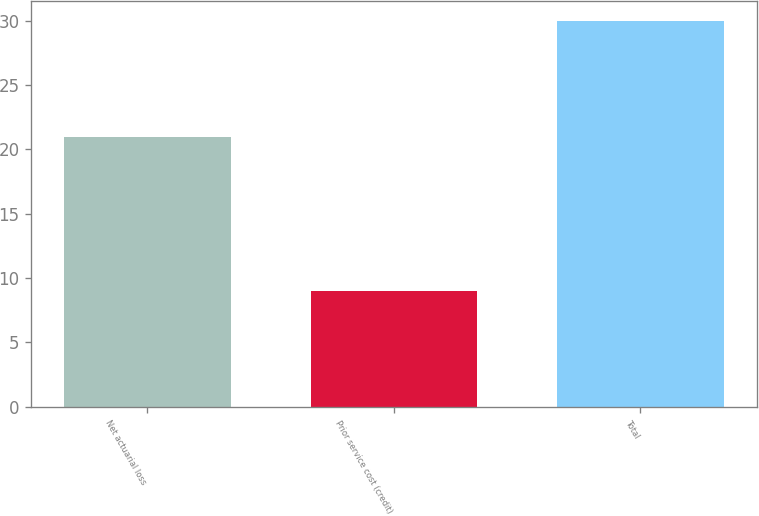<chart> <loc_0><loc_0><loc_500><loc_500><bar_chart><fcel>Net actuarial loss<fcel>Prior service cost (credit)<fcel>Total<nl><fcel>21<fcel>9<fcel>30<nl></chart> 